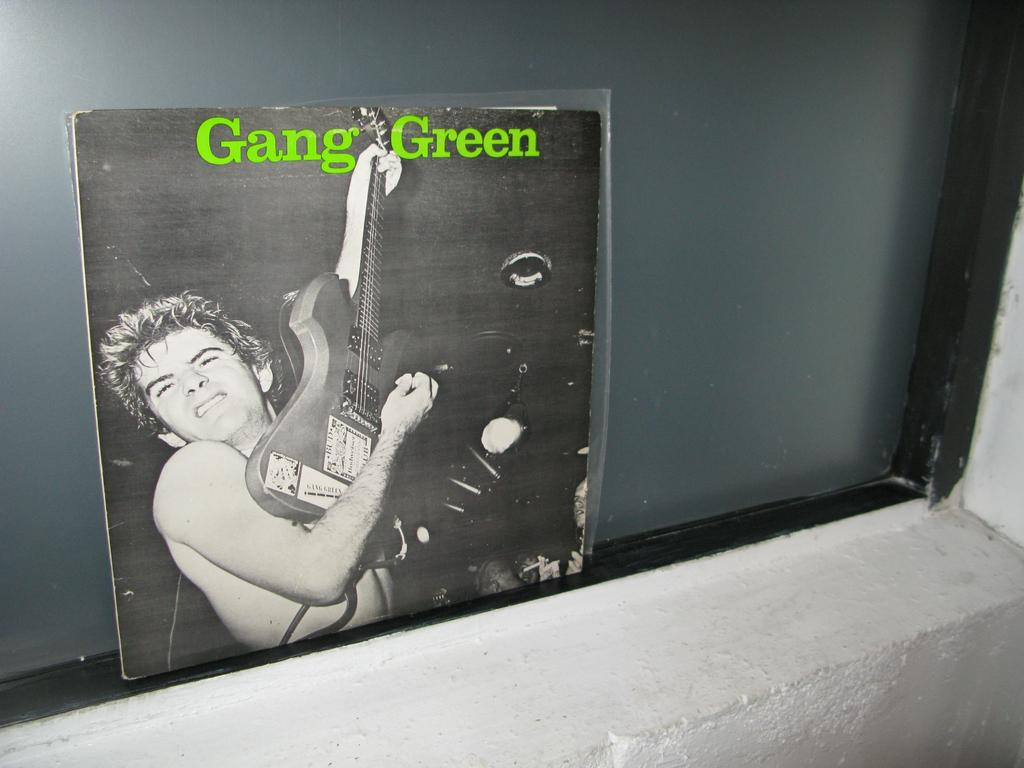What can be seen through the window in the image? The facts provided do not mention anything visible through the window. What is the main subject of the cover page in the image? There is a person playing the guitar on the cover page. What color is the background of the cover page? The background of the cover page is in black color. What type of wall is visible in the image? There is a white wall in the image. What type of machine is being used for business purposes in the image? There is no machine or business activity depicted in the image. What is the person's reaction to the surprise in the image? There is no surprise or reaction visible in the image. 